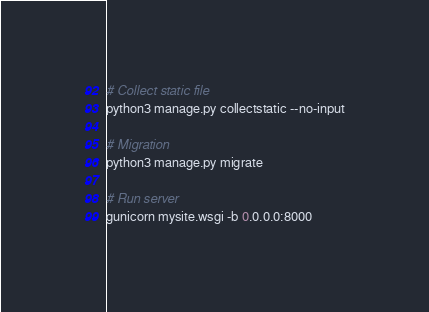<code> <loc_0><loc_0><loc_500><loc_500><_Bash_># Collect static file
python3 manage.py collectstatic --no-input

# Migration
python3 manage.py migrate

# Run server
gunicorn mysite.wsgi -b 0.0.0.0:8000

</code> 